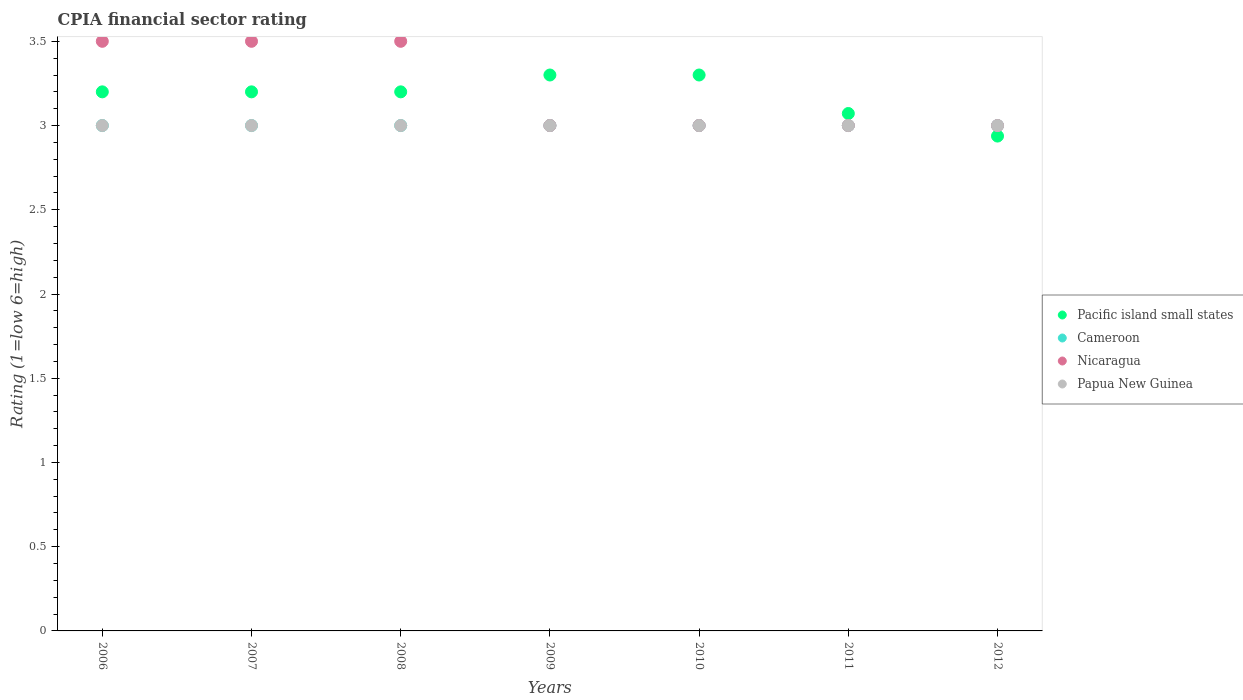How many different coloured dotlines are there?
Ensure brevity in your answer.  4. Is the number of dotlines equal to the number of legend labels?
Your answer should be very brief. Yes. What is the CPIA rating in Pacific island small states in 2006?
Your answer should be compact. 3.2. Across all years, what is the minimum CPIA rating in Cameroon?
Provide a short and direct response. 3. In which year was the CPIA rating in Papua New Guinea minimum?
Your answer should be compact. 2006. What is the total CPIA rating in Papua New Guinea in the graph?
Ensure brevity in your answer.  21. What is the difference between the CPIA rating in Cameroon in 2006 and that in 2010?
Keep it short and to the point. 0. What is the difference between the CPIA rating in Papua New Guinea in 2007 and the CPIA rating in Cameroon in 2010?
Keep it short and to the point. 0. What is the average CPIA rating in Cameroon per year?
Your answer should be very brief. 3. In the year 2007, what is the difference between the CPIA rating in Pacific island small states and CPIA rating in Nicaragua?
Ensure brevity in your answer.  -0.3. What is the difference between the highest and the second highest CPIA rating in Nicaragua?
Offer a very short reply. 0. What is the difference between the highest and the lowest CPIA rating in Cameroon?
Your answer should be very brief. 0. Is it the case that in every year, the sum of the CPIA rating in Nicaragua and CPIA rating in Pacific island small states  is greater than the sum of CPIA rating in Papua New Guinea and CPIA rating in Cameroon?
Offer a terse response. No. Is it the case that in every year, the sum of the CPIA rating in Papua New Guinea and CPIA rating in Pacific island small states  is greater than the CPIA rating in Cameroon?
Your answer should be compact. Yes. Is the CPIA rating in Cameroon strictly greater than the CPIA rating in Nicaragua over the years?
Provide a short and direct response. No. Is the CPIA rating in Pacific island small states strictly less than the CPIA rating in Cameroon over the years?
Give a very brief answer. No. How many dotlines are there?
Your response must be concise. 4. How many years are there in the graph?
Keep it short and to the point. 7. What is the difference between two consecutive major ticks on the Y-axis?
Provide a succinct answer. 0.5. Are the values on the major ticks of Y-axis written in scientific E-notation?
Offer a very short reply. No. Where does the legend appear in the graph?
Your answer should be very brief. Center right. How many legend labels are there?
Your response must be concise. 4. What is the title of the graph?
Provide a succinct answer. CPIA financial sector rating. What is the label or title of the Y-axis?
Keep it short and to the point. Rating (1=low 6=high). What is the Rating (1=low 6=high) of Cameroon in 2006?
Your answer should be very brief. 3. What is the Rating (1=low 6=high) of Nicaragua in 2006?
Make the answer very short. 3.5. What is the Rating (1=low 6=high) of Papua New Guinea in 2006?
Keep it short and to the point. 3. What is the Rating (1=low 6=high) in Nicaragua in 2009?
Ensure brevity in your answer.  3. What is the Rating (1=low 6=high) in Pacific island small states in 2010?
Your answer should be very brief. 3.3. What is the Rating (1=low 6=high) of Pacific island small states in 2011?
Offer a very short reply. 3.07. What is the Rating (1=low 6=high) of Nicaragua in 2011?
Offer a very short reply. 3. What is the Rating (1=low 6=high) of Papua New Guinea in 2011?
Ensure brevity in your answer.  3. What is the Rating (1=low 6=high) in Pacific island small states in 2012?
Your answer should be very brief. 2.94. What is the Rating (1=low 6=high) of Papua New Guinea in 2012?
Ensure brevity in your answer.  3. Across all years, what is the maximum Rating (1=low 6=high) of Pacific island small states?
Your answer should be compact. 3.3. Across all years, what is the minimum Rating (1=low 6=high) of Pacific island small states?
Keep it short and to the point. 2.94. Across all years, what is the minimum Rating (1=low 6=high) in Cameroon?
Your response must be concise. 3. Across all years, what is the minimum Rating (1=low 6=high) of Papua New Guinea?
Keep it short and to the point. 3. What is the total Rating (1=low 6=high) in Pacific island small states in the graph?
Ensure brevity in your answer.  22.21. What is the total Rating (1=low 6=high) of Papua New Guinea in the graph?
Give a very brief answer. 21. What is the difference between the Rating (1=low 6=high) in Nicaragua in 2006 and that in 2007?
Your answer should be very brief. 0. What is the difference between the Rating (1=low 6=high) of Nicaragua in 2006 and that in 2008?
Provide a short and direct response. 0. What is the difference between the Rating (1=low 6=high) in Papua New Guinea in 2006 and that in 2008?
Provide a short and direct response. 0. What is the difference between the Rating (1=low 6=high) of Pacific island small states in 2006 and that in 2009?
Your response must be concise. -0.1. What is the difference between the Rating (1=low 6=high) in Cameroon in 2006 and that in 2009?
Provide a succinct answer. 0. What is the difference between the Rating (1=low 6=high) in Nicaragua in 2006 and that in 2009?
Provide a succinct answer. 0.5. What is the difference between the Rating (1=low 6=high) of Cameroon in 2006 and that in 2010?
Keep it short and to the point. 0. What is the difference between the Rating (1=low 6=high) of Papua New Guinea in 2006 and that in 2010?
Provide a short and direct response. 0. What is the difference between the Rating (1=low 6=high) of Pacific island small states in 2006 and that in 2011?
Offer a very short reply. 0.13. What is the difference between the Rating (1=low 6=high) in Cameroon in 2006 and that in 2011?
Your response must be concise. 0. What is the difference between the Rating (1=low 6=high) of Pacific island small states in 2006 and that in 2012?
Your answer should be compact. 0.26. What is the difference between the Rating (1=low 6=high) of Nicaragua in 2006 and that in 2012?
Offer a terse response. 0.5. What is the difference between the Rating (1=low 6=high) of Pacific island small states in 2007 and that in 2008?
Provide a short and direct response. 0. What is the difference between the Rating (1=low 6=high) of Cameroon in 2007 and that in 2008?
Keep it short and to the point. 0. What is the difference between the Rating (1=low 6=high) in Nicaragua in 2007 and that in 2008?
Provide a short and direct response. 0. What is the difference between the Rating (1=low 6=high) in Nicaragua in 2007 and that in 2009?
Make the answer very short. 0.5. What is the difference between the Rating (1=low 6=high) of Papua New Guinea in 2007 and that in 2009?
Your answer should be very brief. 0. What is the difference between the Rating (1=low 6=high) of Cameroon in 2007 and that in 2010?
Make the answer very short. 0. What is the difference between the Rating (1=low 6=high) of Nicaragua in 2007 and that in 2010?
Offer a terse response. 0.5. What is the difference between the Rating (1=low 6=high) of Papua New Guinea in 2007 and that in 2010?
Your answer should be compact. 0. What is the difference between the Rating (1=low 6=high) in Pacific island small states in 2007 and that in 2011?
Offer a very short reply. 0.13. What is the difference between the Rating (1=low 6=high) of Cameroon in 2007 and that in 2011?
Your answer should be compact. 0. What is the difference between the Rating (1=low 6=high) of Papua New Guinea in 2007 and that in 2011?
Offer a very short reply. 0. What is the difference between the Rating (1=low 6=high) of Pacific island small states in 2007 and that in 2012?
Provide a succinct answer. 0.26. What is the difference between the Rating (1=low 6=high) in Cameroon in 2007 and that in 2012?
Offer a terse response. 0. What is the difference between the Rating (1=low 6=high) in Nicaragua in 2007 and that in 2012?
Your response must be concise. 0.5. What is the difference between the Rating (1=low 6=high) in Papua New Guinea in 2007 and that in 2012?
Ensure brevity in your answer.  0. What is the difference between the Rating (1=low 6=high) of Pacific island small states in 2008 and that in 2009?
Your answer should be compact. -0.1. What is the difference between the Rating (1=low 6=high) in Nicaragua in 2008 and that in 2009?
Give a very brief answer. 0.5. What is the difference between the Rating (1=low 6=high) in Nicaragua in 2008 and that in 2010?
Your response must be concise. 0.5. What is the difference between the Rating (1=low 6=high) of Papua New Guinea in 2008 and that in 2010?
Make the answer very short. 0. What is the difference between the Rating (1=low 6=high) in Pacific island small states in 2008 and that in 2011?
Your answer should be compact. 0.13. What is the difference between the Rating (1=low 6=high) of Cameroon in 2008 and that in 2011?
Your answer should be compact. 0. What is the difference between the Rating (1=low 6=high) of Nicaragua in 2008 and that in 2011?
Provide a succinct answer. 0.5. What is the difference between the Rating (1=low 6=high) of Pacific island small states in 2008 and that in 2012?
Your response must be concise. 0.26. What is the difference between the Rating (1=low 6=high) of Cameroon in 2008 and that in 2012?
Your answer should be very brief. 0. What is the difference between the Rating (1=low 6=high) of Papua New Guinea in 2008 and that in 2012?
Keep it short and to the point. 0. What is the difference between the Rating (1=low 6=high) of Pacific island small states in 2009 and that in 2011?
Make the answer very short. 0.23. What is the difference between the Rating (1=low 6=high) of Cameroon in 2009 and that in 2011?
Offer a terse response. 0. What is the difference between the Rating (1=low 6=high) of Nicaragua in 2009 and that in 2011?
Give a very brief answer. 0. What is the difference between the Rating (1=low 6=high) in Pacific island small states in 2009 and that in 2012?
Provide a short and direct response. 0.36. What is the difference between the Rating (1=low 6=high) in Pacific island small states in 2010 and that in 2011?
Keep it short and to the point. 0.23. What is the difference between the Rating (1=low 6=high) in Nicaragua in 2010 and that in 2011?
Keep it short and to the point. 0. What is the difference between the Rating (1=low 6=high) of Pacific island small states in 2010 and that in 2012?
Your answer should be very brief. 0.36. What is the difference between the Rating (1=low 6=high) of Cameroon in 2010 and that in 2012?
Make the answer very short. 0. What is the difference between the Rating (1=low 6=high) of Nicaragua in 2010 and that in 2012?
Keep it short and to the point. 0. What is the difference between the Rating (1=low 6=high) of Pacific island small states in 2011 and that in 2012?
Your answer should be compact. 0.13. What is the difference between the Rating (1=low 6=high) of Cameroon in 2011 and that in 2012?
Provide a short and direct response. 0. What is the difference between the Rating (1=low 6=high) of Papua New Guinea in 2011 and that in 2012?
Provide a short and direct response. 0. What is the difference between the Rating (1=low 6=high) of Pacific island small states in 2006 and the Rating (1=low 6=high) of Cameroon in 2007?
Provide a short and direct response. 0.2. What is the difference between the Rating (1=low 6=high) in Pacific island small states in 2006 and the Rating (1=low 6=high) in Nicaragua in 2007?
Provide a short and direct response. -0.3. What is the difference between the Rating (1=low 6=high) of Nicaragua in 2006 and the Rating (1=low 6=high) of Papua New Guinea in 2007?
Your response must be concise. 0.5. What is the difference between the Rating (1=low 6=high) in Pacific island small states in 2006 and the Rating (1=low 6=high) in Papua New Guinea in 2008?
Provide a short and direct response. 0.2. What is the difference between the Rating (1=low 6=high) in Cameroon in 2006 and the Rating (1=low 6=high) in Nicaragua in 2008?
Make the answer very short. -0.5. What is the difference between the Rating (1=low 6=high) of Nicaragua in 2006 and the Rating (1=low 6=high) of Papua New Guinea in 2008?
Ensure brevity in your answer.  0.5. What is the difference between the Rating (1=low 6=high) in Cameroon in 2006 and the Rating (1=low 6=high) in Papua New Guinea in 2009?
Ensure brevity in your answer.  0. What is the difference between the Rating (1=low 6=high) of Nicaragua in 2006 and the Rating (1=low 6=high) of Papua New Guinea in 2009?
Provide a succinct answer. 0.5. What is the difference between the Rating (1=low 6=high) in Pacific island small states in 2006 and the Rating (1=low 6=high) in Cameroon in 2010?
Provide a short and direct response. 0.2. What is the difference between the Rating (1=low 6=high) in Nicaragua in 2006 and the Rating (1=low 6=high) in Papua New Guinea in 2010?
Make the answer very short. 0.5. What is the difference between the Rating (1=low 6=high) of Pacific island small states in 2006 and the Rating (1=low 6=high) of Cameroon in 2011?
Keep it short and to the point. 0.2. What is the difference between the Rating (1=low 6=high) of Pacific island small states in 2006 and the Rating (1=low 6=high) of Nicaragua in 2011?
Your response must be concise. 0.2. What is the difference between the Rating (1=low 6=high) of Pacific island small states in 2006 and the Rating (1=low 6=high) of Papua New Guinea in 2011?
Ensure brevity in your answer.  0.2. What is the difference between the Rating (1=low 6=high) in Cameroon in 2006 and the Rating (1=low 6=high) in Nicaragua in 2011?
Offer a terse response. 0. What is the difference between the Rating (1=low 6=high) of Nicaragua in 2006 and the Rating (1=low 6=high) of Papua New Guinea in 2011?
Your answer should be very brief. 0.5. What is the difference between the Rating (1=low 6=high) in Pacific island small states in 2006 and the Rating (1=low 6=high) in Cameroon in 2012?
Make the answer very short. 0.2. What is the difference between the Rating (1=low 6=high) in Pacific island small states in 2006 and the Rating (1=low 6=high) in Papua New Guinea in 2012?
Provide a succinct answer. 0.2. What is the difference between the Rating (1=low 6=high) of Cameroon in 2006 and the Rating (1=low 6=high) of Papua New Guinea in 2012?
Provide a short and direct response. 0. What is the difference between the Rating (1=low 6=high) of Nicaragua in 2006 and the Rating (1=low 6=high) of Papua New Guinea in 2012?
Provide a succinct answer. 0.5. What is the difference between the Rating (1=low 6=high) of Pacific island small states in 2007 and the Rating (1=low 6=high) of Cameroon in 2008?
Your response must be concise. 0.2. What is the difference between the Rating (1=low 6=high) of Cameroon in 2007 and the Rating (1=low 6=high) of Nicaragua in 2008?
Keep it short and to the point. -0.5. What is the difference between the Rating (1=low 6=high) in Nicaragua in 2007 and the Rating (1=low 6=high) in Papua New Guinea in 2008?
Keep it short and to the point. 0.5. What is the difference between the Rating (1=low 6=high) in Pacific island small states in 2007 and the Rating (1=low 6=high) in Nicaragua in 2009?
Offer a very short reply. 0.2. What is the difference between the Rating (1=low 6=high) of Pacific island small states in 2007 and the Rating (1=low 6=high) of Papua New Guinea in 2009?
Provide a short and direct response. 0.2. What is the difference between the Rating (1=low 6=high) in Cameroon in 2007 and the Rating (1=low 6=high) in Nicaragua in 2009?
Ensure brevity in your answer.  0. What is the difference between the Rating (1=low 6=high) in Cameroon in 2007 and the Rating (1=low 6=high) in Papua New Guinea in 2009?
Make the answer very short. 0. What is the difference between the Rating (1=low 6=high) in Pacific island small states in 2007 and the Rating (1=low 6=high) in Cameroon in 2010?
Ensure brevity in your answer.  0.2. What is the difference between the Rating (1=low 6=high) in Pacific island small states in 2007 and the Rating (1=low 6=high) in Nicaragua in 2010?
Make the answer very short. 0.2. What is the difference between the Rating (1=low 6=high) of Cameroon in 2007 and the Rating (1=low 6=high) of Nicaragua in 2010?
Ensure brevity in your answer.  0. What is the difference between the Rating (1=low 6=high) in Cameroon in 2007 and the Rating (1=low 6=high) in Papua New Guinea in 2010?
Your answer should be very brief. 0. What is the difference between the Rating (1=low 6=high) in Nicaragua in 2007 and the Rating (1=low 6=high) in Papua New Guinea in 2010?
Your answer should be very brief. 0.5. What is the difference between the Rating (1=low 6=high) in Pacific island small states in 2007 and the Rating (1=low 6=high) in Cameroon in 2011?
Give a very brief answer. 0.2. What is the difference between the Rating (1=low 6=high) in Pacific island small states in 2007 and the Rating (1=low 6=high) in Nicaragua in 2011?
Ensure brevity in your answer.  0.2. What is the difference between the Rating (1=low 6=high) in Pacific island small states in 2007 and the Rating (1=low 6=high) in Papua New Guinea in 2011?
Ensure brevity in your answer.  0.2. What is the difference between the Rating (1=low 6=high) in Cameroon in 2007 and the Rating (1=low 6=high) in Nicaragua in 2011?
Offer a very short reply. 0. What is the difference between the Rating (1=low 6=high) in Pacific island small states in 2007 and the Rating (1=low 6=high) in Nicaragua in 2012?
Ensure brevity in your answer.  0.2. What is the difference between the Rating (1=low 6=high) in Pacific island small states in 2007 and the Rating (1=low 6=high) in Papua New Guinea in 2012?
Give a very brief answer. 0.2. What is the difference between the Rating (1=low 6=high) in Cameroon in 2007 and the Rating (1=low 6=high) in Nicaragua in 2012?
Ensure brevity in your answer.  0. What is the difference between the Rating (1=low 6=high) of Cameroon in 2007 and the Rating (1=low 6=high) of Papua New Guinea in 2012?
Give a very brief answer. 0. What is the difference between the Rating (1=low 6=high) of Pacific island small states in 2008 and the Rating (1=low 6=high) of Cameroon in 2009?
Make the answer very short. 0.2. What is the difference between the Rating (1=low 6=high) of Pacific island small states in 2008 and the Rating (1=low 6=high) of Papua New Guinea in 2009?
Keep it short and to the point. 0.2. What is the difference between the Rating (1=low 6=high) in Pacific island small states in 2008 and the Rating (1=low 6=high) in Nicaragua in 2010?
Give a very brief answer. 0.2. What is the difference between the Rating (1=low 6=high) in Pacific island small states in 2008 and the Rating (1=low 6=high) in Papua New Guinea in 2010?
Make the answer very short. 0.2. What is the difference between the Rating (1=low 6=high) of Nicaragua in 2008 and the Rating (1=low 6=high) of Papua New Guinea in 2010?
Provide a short and direct response. 0.5. What is the difference between the Rating (1=low 6=high) of Pacific island small states in 2008 and the Rating (1=low 6=high) of Nicaragua in 2011?
Provide a succinct answer. 0.2. What is the difference between the Rating (1=low 6=high) of Cameroon in 2008 and the Rating (1=low 6=high) of Nicaragua in 2011?
Ensure brevity in your answer.  0. What is the difference between the Rating (1=low 6=high) in Pacific island small states in 2008 and the Rating (1=low 6=high) in Nicaragua in 2012?
Provide a succinct answer. 0.2. What is the difference between the Rating (1=low 6=high) in Cameroon in 2008 and the Rating (1=low 6=high) in Papua New Guinea in 2012?
Make the answer very short. 0. What is the difference between the Rating (1=low 6=high) of Nicaragua in 2008 and the Rating (1=low 6=high) of Papua New Guinea in 2012?
Your answer should be very brief. 0.5. What is the difference between the Rating (1=low 6=high) in Cameroon in 2009 and the Rating (1=low 6=high) in Papua New Guinea in 2010?
Ensure brevity in your answer.  0. What is the difference between the Rating (1=low 6=high) of Pacific island small states in 2009 and the Rating (1=low 6=high) of Cameroon in 2011?
Offer a very short reply. 0.3. What is the difference between the Rating (1=low 6=high) in Pacific island small states in 2009 and the Rating (1=low 6=high) in Papua New Guinea in 2011?
Give a very brief answer. 0.3. What is the difference between the Rating (1=low 6=high) in Cameroon in 2009 and the Rating (1=low 6=high) in Nicaragua in 2011?
Keep it short and to the point. 0. What is the difference between the Rating (1=low 6=high) in Pacific island small states in 2009 and the Rating (1=low 6=high) in Cameroon in 2012?
Your answer should be very brief. 0.3. What is the difference between the Rating (1=low 6=high) of Pacific island small states in 2009 and the Rating (1=low 6=high) of Nicaragua in 2012?
Make the answer very short. 0.3. What is the difference between the Rating (1=low 6=high) of Pacific island small states in 2009 and the Rating (1=low 6=high) of Papua New Guinea in 2012?
Make the answer very short. 0.3. What is the difference between the Rating (1=low 6=high) of Cameroon in 2009 and the Rating (1=low 6=high) of Nicaragua in 2012?
Your answer should be compact. 0. What is the difference between the Rating (1=low 6=high) of Pacific island small states in 2010 and the Rating (1=low 6=high) of Cameroon in 2011?
Your response must be concise. 0.3. What is the difference between the Rating (1=low 6=high) of Pacific island small states in 2010 and the Rating (1=low 6=high) of Papua New Guinea in 2012?
Your answer should be very brief. 0.3. What is the difference between the Rating (1=low 6=high) in Cameroon in 2010 and the Rating (1=low 6=high) in Papua New Guinea in 2012?
Offer a terse response. 0. What is the difference between the Rating (1=low 6=high) in Nicaragua in 2010 and the Rating (1=low 6=high) in Papua New Guinea in 2012?
Provide a short and direct response. 0. What is the difference between the Rating (1=low 6=high) in Pacific island small states in 2011 and the Rating (1=low 6=high) in Cameroon in 2012?
Offer a very short reply. 0.07. What is the difference between the Rating (1=low 6=high) in Pacific island small states in 2011 and the Rating (1=low 6=high) in Nicaragua in 2012?
Keep it short and to the point. 0.07. What is the difference between the Rating (1=low 6=high) of Pacific island small states in 2011 and the Rating (1=low 6=high) of Papua New Guinea in 2012?
Provide a short and direct response. 0.07. What is the difference between the Rating (1=low 6=high) of Nicaragua in 2011 and the Rating (1=low 6=high) of Papua New Guinea in 2012?
Keep it short and to the point. 0. What is the average Rating (1=low 6=high) of Pacific island small states per year?
Your answer should be compact. 3.17. What is the average Rating (1=low 6=high) in Cameroon per year?
Your response must be concise. 3. What is the average Rating (1=low 6=high) of Nicaragua per year?
Your answer should be very brief. 3.21. What is the average Rating (1=low 6=high) of Papua New Guinea per year?
Your answer should be compact. 3. In the year 2006, what is the difference between the Rating (1=low 6=high) in Pacific island small states and Rating (1=low 6=high) in Cameroon?
Give a very brief answer. 0.2. In the year 2006, what is the difference between the Rating (1=low 6=high) of Pacific island small states and Rating (1=low 6=high) of Nicaragua?
Provide a short and direct response. -0.3. In the year 2006, what is the difference between the Rating (1=low 6=high) in Pacific island small states and Rating (1=low 6=high) in Papua New Guinea?
Ensure brevity in your answer.  0.2. In the year 2006, what is the difference between the Rating (1=low 6=high) in Cameroon and Rating (1=low 6=high) in Nicaragua?
Offer a terse response. -0.5. In the year 2007, what is the difference between the Rating (1=low 6=high) of Pacific island small states and Rating (1=low 6=high) of Cameroon?
Keep it short and to the point. 0.2. In the year 2007, what is the difference between the Rating (1=low 6=high) in Pacific island small states and Rating (1=low 6=high) in Nicaragua?
Offer a very short reply. -0.3. In the year 2007, what is the difference between the Rating (1=low 6=high) in Cameroon and Rating (1=low 6=high) in Nicaragua?
Provide a succinct answer. -0.5. In the year 2008, what is the difference between the Rating (1=low 6=high) of Pacific island small states and Rating (1=low 6=high) of Nicaragua?
Give a very brief answer. -0.3. In the year 2008, what is the difference between the Rating (1=low 6=high) of Cameroon and Rating (1=low 6=high) of Nicaragua?
Keep it short and to the point. -0.5. In the year 2008, what is the difference between the Rating (1=low 6=high) of Cameroon and Rating (1=low 6=high) of Papua New Guinea?
Your response must be concise. 0. In the year 2009, what is the difference between the Rating (1=low 6=high) in Pacific island small states and Rating (1=low 6=high) in Cameroon?
Keep it short and to the point. 0.3. In the year 2009, what is the difference between the Rating (1=low 6=high) of Pacific island small states and Rating (1=low 6=high) of Nicaragua?
Provide a short and direct response. 0.3. In the year 2009, what is the difference between the Rating (1=low 6=high) of Pacific island small states and Rating (1=low 6=high) of Papua New Guinea?
Your answer should be compact. 0.3. In the year 2009, what is the difference between the Rating (1=low 6=high) in Cameroon and Rating (1=low 6=high) in Nicaragua?
Your response must be concise. 0. In the year 2009, what is the difference between the Rating (1=low 6=high) in Cameroon and Rating (1=low 6=high) in Papua New Guinea?
Your answer should be very brief. 0. In the year 2010, what is the difference between the Rating (1=low 6=high) in Pacific island small states and Rating (1=low 6=high) in Cameroon?
Your answer should be compact. 0.3. In the year 2010, what is the difference between the Rating (1=low 6=high) of Pacific island small states and Rating (1=low 6=high) of Nicaragua?
Provide a succinct answer. 0.3. In the year 2010, what is the difference between the Rating (1=low 6=high) of Nicaragua and Rating (1=low 6=high) of Papua New Guinea?
Offer a very short reply. 0. In the year 2011, what is the difference between the Rating (1=low 6=high) in Pacific island small states and Rating (1=low 6=high) in Cameroon?
Your response must be concise. 0.07. In the year 2011, what is the difference between the Rating (1=low 6=high) in Pacific island small states and Rating (1=low 6=high) in Nicaragua?
Your response must be concise. 0.07. In the year 2011, what is the difference between the Rating (1=low 6=high) of Pacific island small states and Rating (1=low 6=high) of Papua New Guinea?
Your answer should be very brief. 0.07. In the year 2011, what is the difference between the Rating (1=low 6=high) in Cameroon and Rating (1=low 6=high) in Nicaragua?
Your answer should be compact. 0. In the year 2012, what is the difference between the Rating (1=low 6=high) of Pacific island small states and Rating (1=low 6=high) of Cameroon?
Give a very brief answer. -0.06. In the year 2012, what is the difference between the Rating (1=low 6=high) in Pacific island small states and Rating (1=low 6=high) in Nicaragua?
Ensure brevity in your answer.  -0.06. In the year 2012, what is the difference between the Rating (1=low 6=high) in Pacific island small states and Rating (1=low 6=high) in Papua New Guinea?
Offer a terse response. -0.06. In the year 2012, what is the difference between the Rating (1=low 6=high) in Cameroon and Rating (1=low 6=high) in Nicaragua?
Ensure brevity in your answer.  0. In the year 2012, what is the difference between the Rating (1=low 6=high) of Cameroon and Rating (1=low 6=high) of Papua New Guinea?
Provide a succinct answer. 0. What is the ratio of the Rating (1=low 6=high) in Pacific island small states in 2006 to that in 2008?
Offer a very short reply. 1. What is the ratio of the Rating (1=low 6=high) of Cameroon in 2006 to that in 2008?
Provide a succinct answer. 1. What is the ratio of the Rating (1=low 6=high) of Papua New Guinea in 2006 to that in 2008?
Your answer should be very brief. 1. What is the ratio of the Rating (1=low 6=high) in Pacific island small states in 2006 to that in 2009?
Give a very brief answer. 0.97. What is the ratio of the Rating (1=low 6=high) of Nicaragua in 2006 to that in 2009?
Give a very brief answer. 1.17. What is the ratio of the Rating (1=low 6=high) in Pacific island small states in 2006 to that in 2010?
Ensure brevity in your answer.  0.97. What is the ratio of the Rating (1=low 6=high) in Cameroon in 2006 to that in 2010?
Make the answer very short. 1. What is the ratio of the Rating (1=low 6=high) in Pacific island small states in 2006 to that in 2011?
Keep it short and to the point. 1.04. What is the ratio of the Rating (1=low 6=high) in Nicaragua in 2006 to that in 2011?
Keep it short and to the point. 1.17. What is the ratio of the Rating (1=low 6=high) of Pacific island small states in 2006 to that in 2012?
Provide a succinct answer. 1.09. What is the ratio of the Rating (1=low 6=high) of Cameroon in 2006 to that in 2012?
Make the answer very short. 1. What is the ratio of the Rating (1=low 6=high) of Papua New Guinea in 2006 to that in 2012?
Keep it short and to the point. 1. What is the ratio of the Rating (1=low 6=high) in Pacific island small states in 2007 to that in 2008?
Provide a succinct answer. 1. What is the ratio of the Rating (1=low 6=high) in Cameroon in 2007 to that in 2008?
Provide a short and direct response. 1. What is the ratio of the Rating (1=low 6=high) in Nicaragua in 2007 to that in 2008?
Provide a succinct answer. 1. What is the ratio of the Rating (1=low 6=high) in Papua New Guinea in 2007 to that in 2008?
Ensure brevity in your answer.  1. What is the ratio of the Rating (1=low 6=high) in Pacific island small states in 2007 to that in 2009?
Offer a very short reply. 0.97. What is the ratio of the Rating (1=low 6=high) in Pacific island small states in 2007 to that in 2010?
Ensure brevity in your answer.  0.97. What is the ratio of the Rating (1=low 6=high) of Cameroon in 2007 to that in 2010?
Ensure brevity in your answer.  1. What is the ratio of the Rating (1=low 6=high) of Pacific island small states in 2007 to that in 2011?
Your answer should be very brief. 1.04. What is the ratio of the Rating (1=low 6=high) of Cameroon in 2007 to that in 2011?
Your response must be concise. 1. What is the ratio of the Rating (1=low 6=high) of Nicaragua in 2007 to that in 2011?
Offer a terse response. 1.17. What is the ratio of the Rating (1=low 6=high) of Papua New Guinea in 2007 to that in 2011?
Give a very brief answer. 1. What is the ratio of the Rating (1=low 6=high) in Pacific island small states in 2007 to that in 2012?
Your response must be concise. 1.09. What is the ratio of the Rating (1=low 6=high) in Pacific island small states in 2008 to that in 2009?
Make the answer very short. 0.97. What is the ratio of the Rating (1=low 6=high) of Cameroon in 2008 to that in 2009?
Ensure brevity in your answer.  1. What is the ratio of the Rating (1=low 6=high) of Papua New Guinea in 2008 to that in 2009?
Offer a terse response. 1. What is the ratio of the Rating (1=low 6=high) in Pacific island small states in 2008 to that in 2010?
Give a very brief answer. 0.97. What is the ratio of the Rating (1=low 6=high) of Nicaragua in 2008 to that in 2010?
Offer a very short reply. 1.17. What is the ratio of the Rating (1=low 6=high) in Pacific island small states in 2008 to that in 2011?
Ensure brevity in your answer.  1.04. What is the ratio of the Rating (1=low 6=high) in Cameroon in 2008 to that in 2011?
Your answer should be very brief. 1. What is the ratio of the Rating (1=low 6=high) of Papua New Guinea in 2008 to that in 2011?
Ensure brevity in your answer.  1. What is the ratio of the Rating (1=low 6=high) of Pacific island small states in 2008 to that in 2012?
Your answer should be compact. 1.09. What is the ratio of the Rating (1=low 6=high) in Papua New Guinea in 2008 to that in 2012?
Your answer should be very brief. 1. What is the ratio of the Rating (1=low 6=high) of Papua New Guinea in 2009 to that in 2010?
Your answer should be compact. 1. What is the ratio of the Rating (1=low 6=high) of Pacific island small states in 2009 to that in 2011?
Provide a short and direct response. 1.07. What is the ratio of the Rating (1=low 6=high) in Pacific island small states in 2009 to that in 2012?
Give a very brief answer. 1.12. What is the ratio of the Rating (1=low 6=high) of Nicaragua in 2009 to that in 2012?
Provide a succinct answer. 1. What is the ratio of the Rating (1=low 6=high) in Papua New Guinea in 2009 to that in 2012?
Offer a very short reply. 1. What is the ratio of the Rating (1=low 6=high) in Pacific island small states in 2010 to that in 2011?
Provide a short and direct response. 1.07. What is the ratio of the Rating (1=low 6=high) in Pacific island small states in 2010 to that in 2012?
Your answer should be compact. 1.12. What is the ratio of the Rating (1=low 6=high) in Cameroon in 2010 to that in 2012?
Provide a succinct answer. 1. What is the ratio of the Rating (1=low 6=high) in Papua New Guinea in 2010 to that in 2012?
Your answer should be very brief. 1. What is the ratio of the Rating (1=low 6=high) of Pacific island small states in 2011 to that in 2012?
Offer a very short reply. 1.05. What is the difference between the highest and the second highest Rating (1=low 6=high) in Pacific island small states?
Offer a very short reply. 0. What is the difference between the highest and the second highest Rating (1=low 6=high) of Cameroon?
Keep it short and to the point. 0. What is the difference between the highest and the lowest Rating (1=low 6=high) of Pacific island small states?
Provide a short and direct response. 0.36. What is the difference between the highest and the lowest Rating (1=low 6=high) in Cameroon?
Keep it short and to the point. 0. What is the difference between the highest and the lowest Rating (1=low 6=high) of Nicaragua?
Offer a very short reply. 0.5. What is the difference between the highest and the lowest Rating (1=low 6=high) of Papua New Guinea?
Ensure brevity in your answer.  0. 